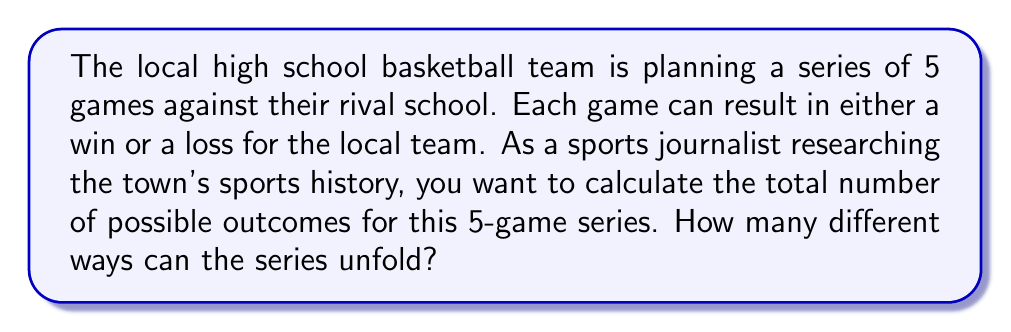Can you answer this question? Let's approach this step-by-step:

1) First, we need to recognize that this is a problem of combinations with repetition. Each game has two possible outcomes (win or loss), and we're looking at a series of 5 games.

2) In combinatorics, this scenario is equivalent to the number of ways to arrange $n$ objects with $k$ types, where repetition is allowed. The formula for this is:

   $$k^n$$

   Where $k$ is the number of types (possible outcomes per game) and $n$ is the number of objects (games in the series).

3) In this case:
   - $k = 2$ (win or loss)
   - $n = 5$ (5 games in the series)

4) Plugging these values into our formula:

   $$2^5$$

5) Now, let's calculate:

   $$2^5 = 2 \times 2 \times 2 \times 2 \times 2 = 32$$

Therefore, there are 32 different possible outcomes for the 5-game series.
Answer: $32$ 